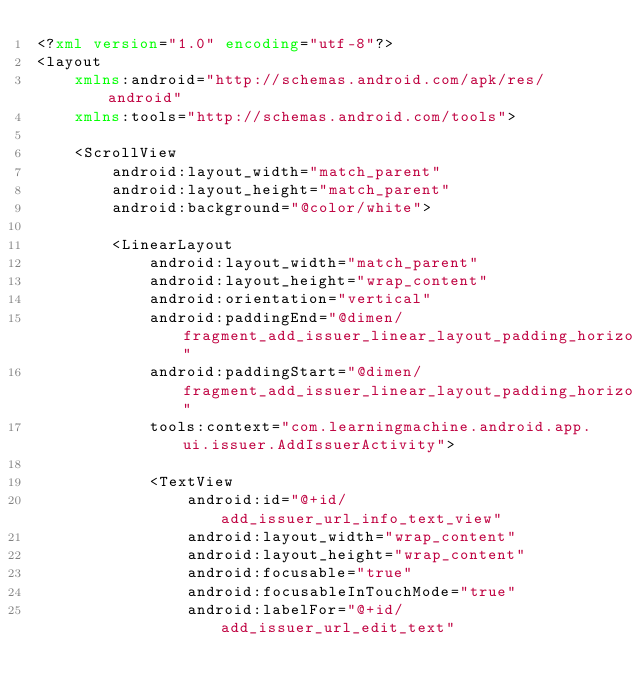<code> <loc_0><loc_0><loc_500><loc_500><_XML_><?xml version="1.0" encoding="utf-8"?>
<layout
    xmlns:android="http://schemas.android.com/apk/res/android"
    xmlns:tools="http://schemas.android.com/tools">

    <ScrollView
        android:layout_width="match_parent"
        android:layout_height="match_parent"
        android:background="@color/white">

        <LinearLayout
            android:layout_width="match_parent"
            android:layout_height="wrap_content"
            android:orientation="vertical"
            android:paddingEnd="@dimen/fragment_add_issuer_linear_layout_padding_horizontal"
            android:paddingStart="@dimen/fragment_add_issuer_linear_layout_padding_horizontal"
            tools:context="com.learningmachine.android.app.ui.issuer.AddIssuerActivity">

            <TextView
                android:id="@+id/add_issuer_url_info_text_view"
                android:layout_width="wrap_content"
                android:layout_height="wrap_content"
                android:focusable="true"
                android:focusableInTouchMode="true"
                android:labelFor="@+id/add_issuer_url_edit_text"</code> 